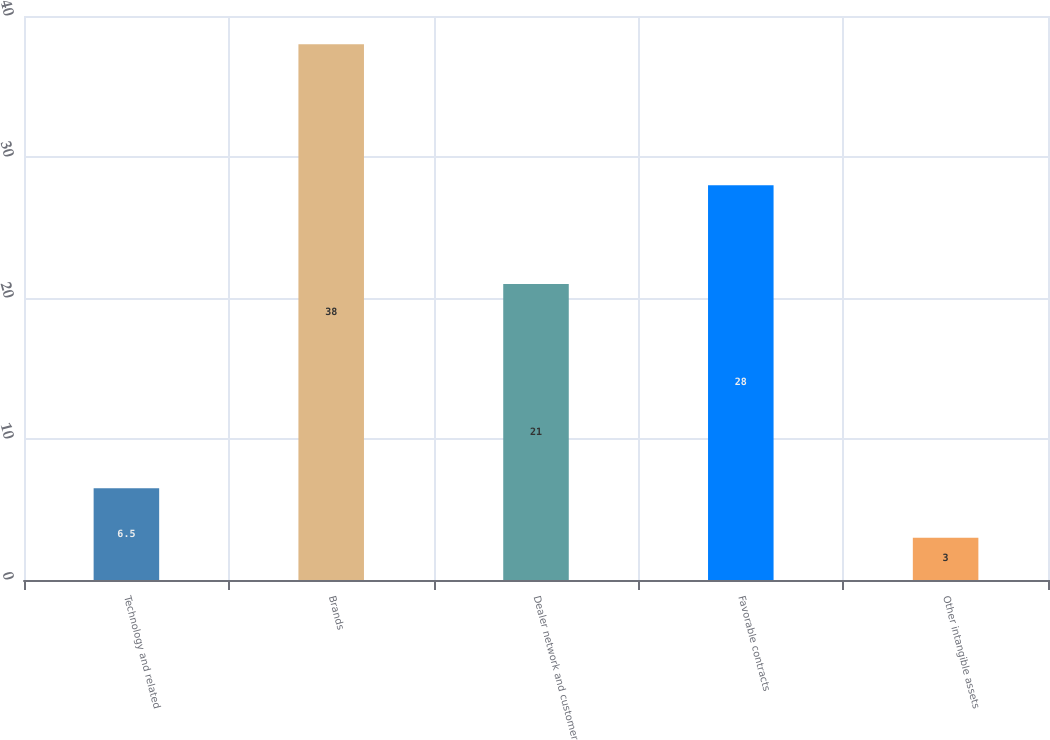<chart> <loc_0><loc_0><loc_500><loc_500><bar_chart><fcel>Technology and related<fcel>Brands<fcel>Dealer network and customer<fcel>Favorable contracts<fcel>Other intangible assets<nl><fcel>6.5<fcel>38<fcel>21<fcel>28<fcel>3<nl></chart> 